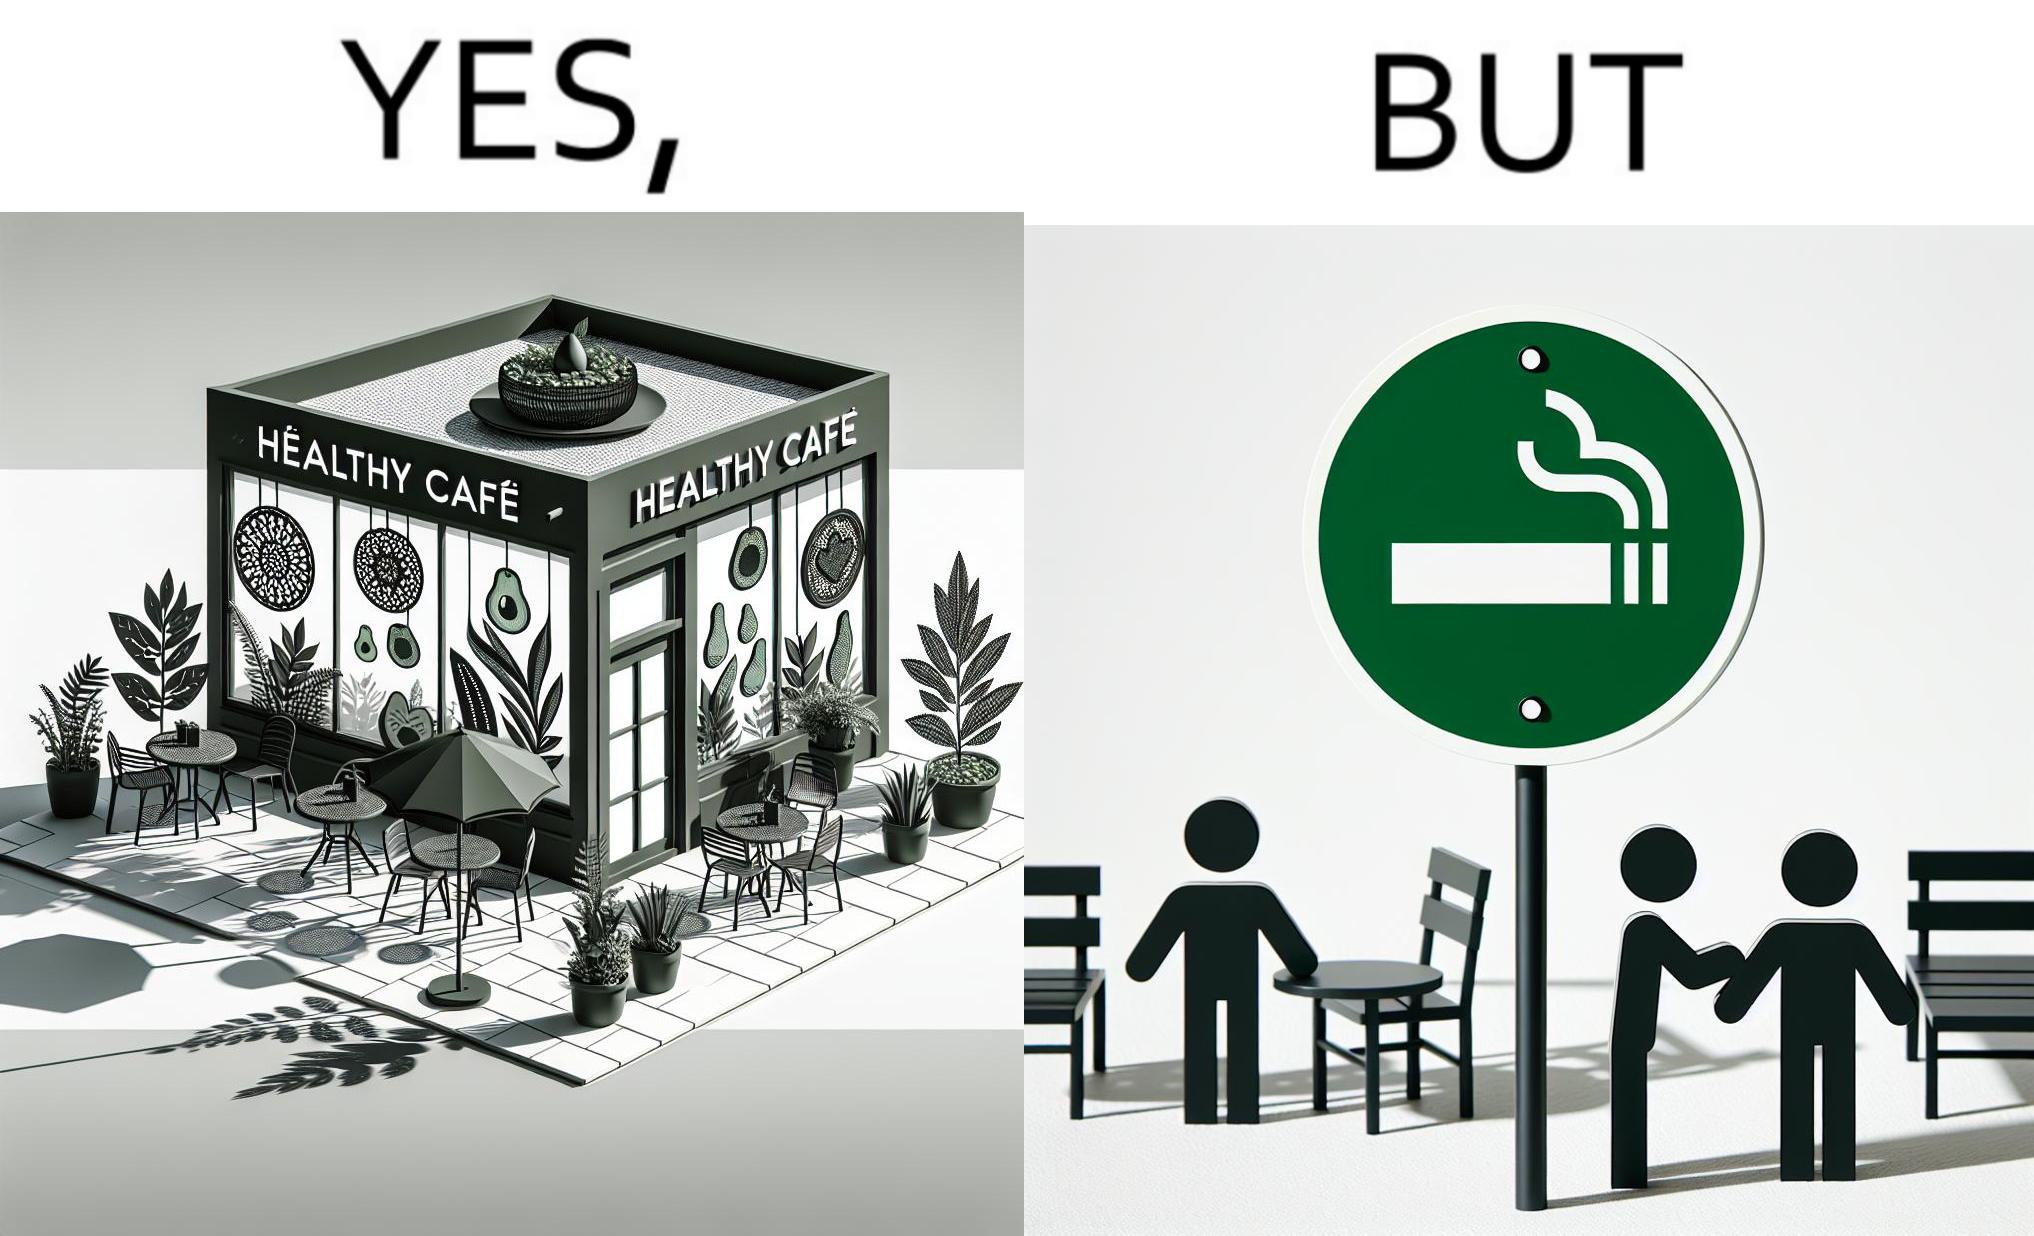What do you see in each half of this image? In the left part of the image: An eatery with the name "Healthy Cafe". It has a green aesthetic with paintings of leaves, avocados, etc on their windows. They have an outdoor seating area with 4 green patio chairs around a circular table. There is a small sign on a stand near the table with a green circular symbol and some text that is too small to read. In the right part of the image: Green patio chairs. A sign on a stand that has a green circular symbol encircling a cigarette symbol, and some text that says "SMOKING AREA". 